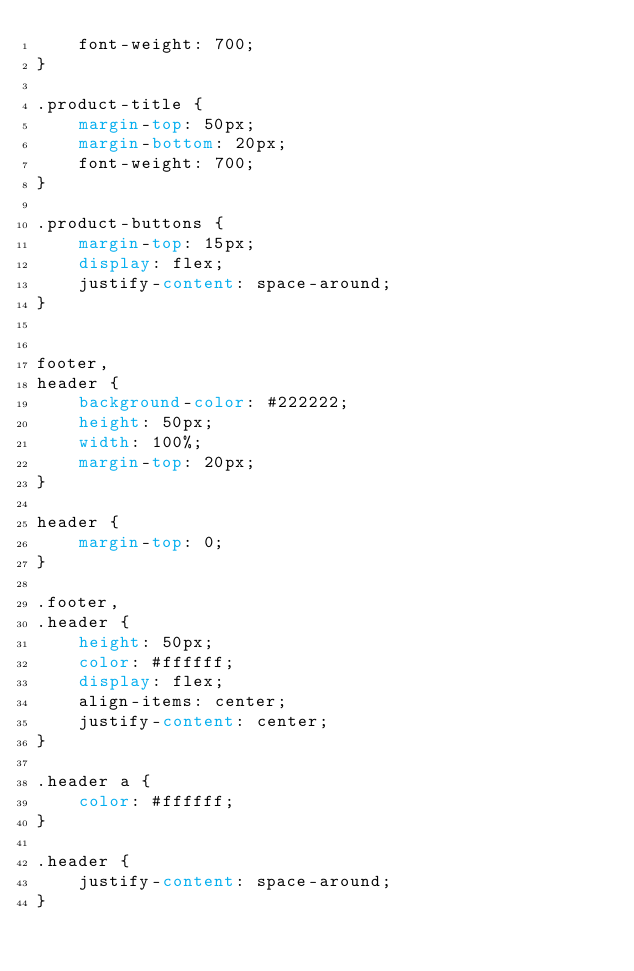<code> <loc_0><loc_0><loc_500><loc_500><_CSS_>    font-weight: 700;
}

.product-title {
    margin-top: 50px;
    margin-bottom: 20px;
    font-weight: 700;
}

.product-buttons {
    margin-top: 15px;
    display: flex;
    justify-content: space-around;
}


footer,
header {
    background-color: #222222;
    height: 50px;
    width: 100%;
    margin-top: 20px;
}

header {
    margin-top: 0;
}

.footer,
.header {
    height: 50px;
    color: #ffffff;
    display: flex;
    align-items: center;
    justify-content: center;
}

.header a {
    color: #ffffff;
}

.header {
    justify-content: space-around;
}</code> 